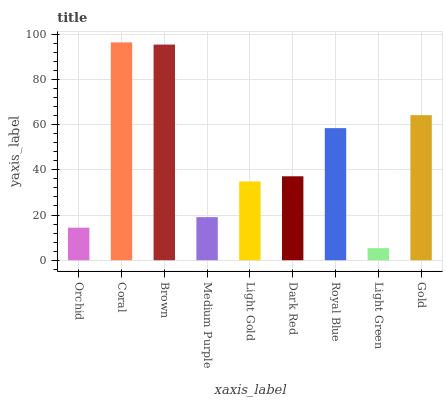Is Light Green the minimum?
Answer yes or no. Yes. Is Coral the maximum?
Answer yes or no. Yes. Is Brown the minimum?
Answer yes or no. No. Is Brown the maximum?
Answer yes or no. No. Is Coral greater than Brown?
Answer yes or no. Yes. Is Brown less than Coral?
Answer yes or no. Yes. Is Brown greater than Coral?
Answer yes or no. No. Is Coral less than Brown?
Answer yes or no. No. Is Dark Red the high median?
Answer yes or no. Yes. Is Dark Red the low median?
Answer yes or no. Yes. Is Light Gold the high median?
Answer yes or no. No. Is Medium Purple the low median?
Answer yes or no. No. 